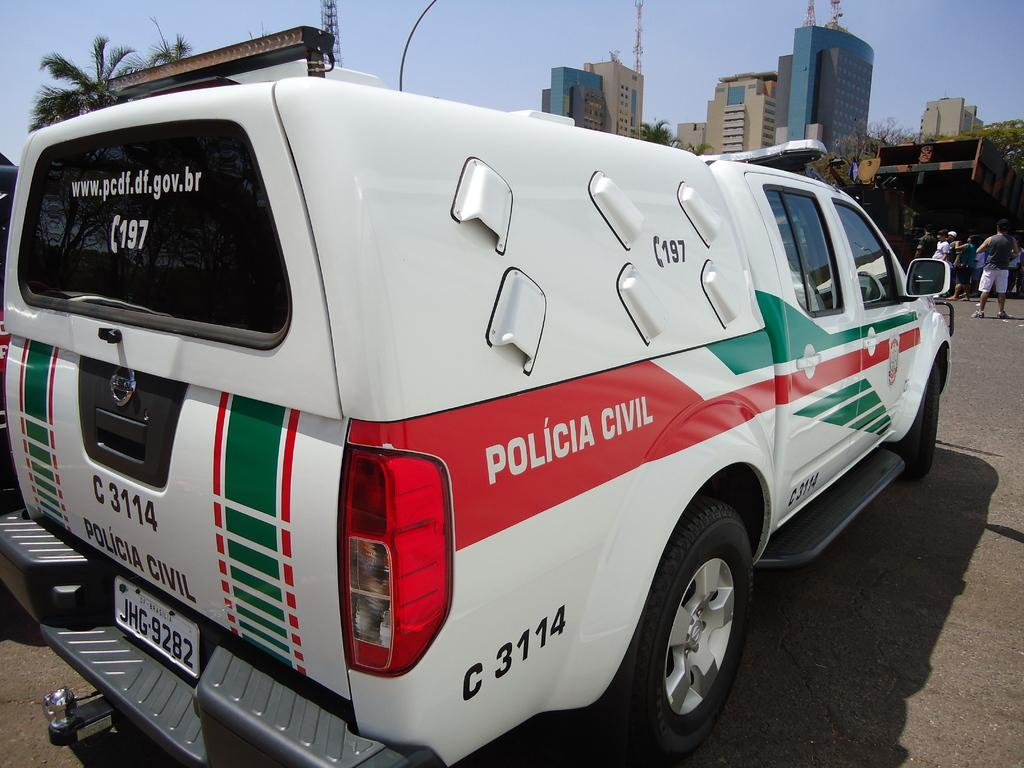Provide a one-sentence caption for the provided image. white Policia Civil truck in a parking lot. 